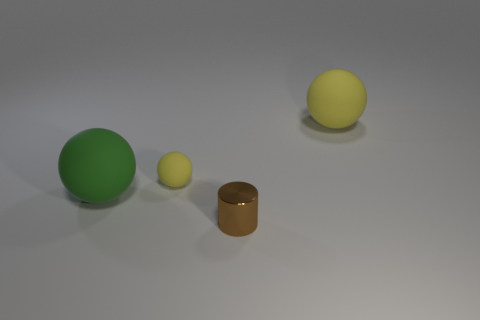Does the tiny rubber thing have the same color as the ball that is on the right side of the tiny brown shiny thing?
Offer a very short reply. Yes. Are there more small metallic cylinders that are behind the large green thing than large yellow balls?
Offer a very short reply. No. Is the green object made of the same material as the brown thing?
Your answer should be compact. No. What number of things are either small things that are in front of the small matte object or matte balls to the left of the metallic cylinder?
Offer a very short reply. 3. What color is the small matte object that is the same shape as the large yellow rubber thing?
Make the answer very short. Yellow. How many large balls are the same color as the small cylinder?
Give a very brief answer. 0. Is the small cylinder the same color as the tiny sphere?
Keep it short and to the point. No. How many things are spheres to the left of the big yellow thing or brown shiny cylinders?
Your response must be concise. 3. What color is the big sphere that is to the right of the big thing that is in front of the large sphere that is right of the tiny brown metallic cylinder?
Provide a short and direct response. Yellow. There is a large thing that is the same material as the large green sphere; what color is it?
Keep it short and to the point. Yellow. 